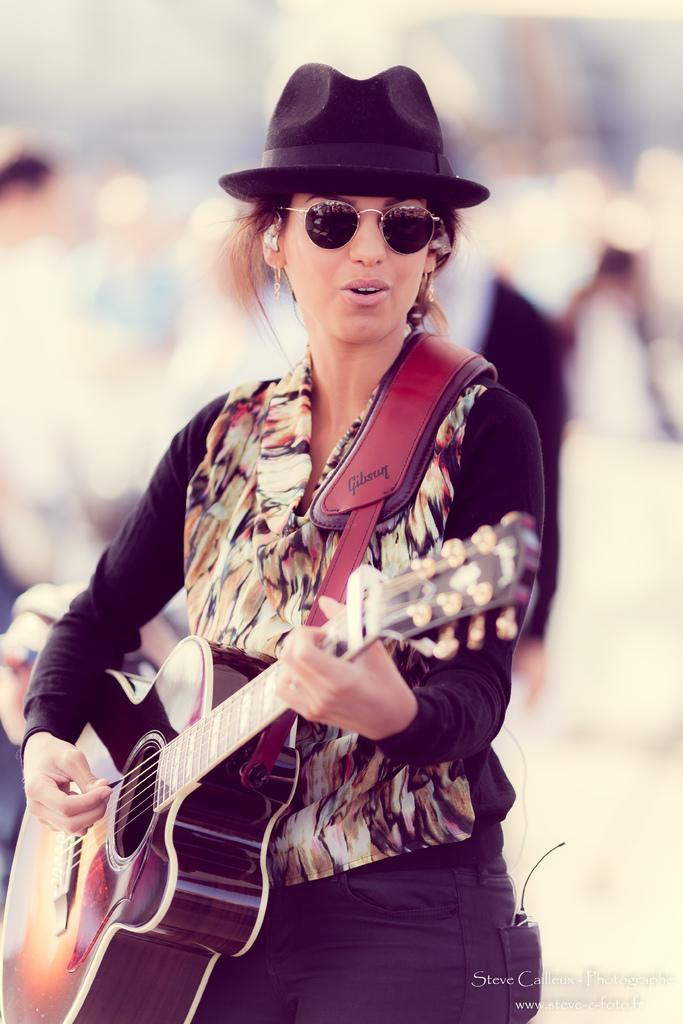What is the main subject of the image? There is a woman in the image. What is the woman doing in the image? The woman is standing and playing a guitar. Can you describe the background of the image? There is a group of people in the background of the image. How would you describe the quality of the image? The image is blurry. Is there any text present in the image? Yes, there is text at the bottom right of the image. What type of pie is being served to the woman in the image? There is no pie present in the image; the woman is playing a guitar. Can you tell me who provided the credit for the woman's guitar in the image? There is no information about credit for the guitar in the image. 